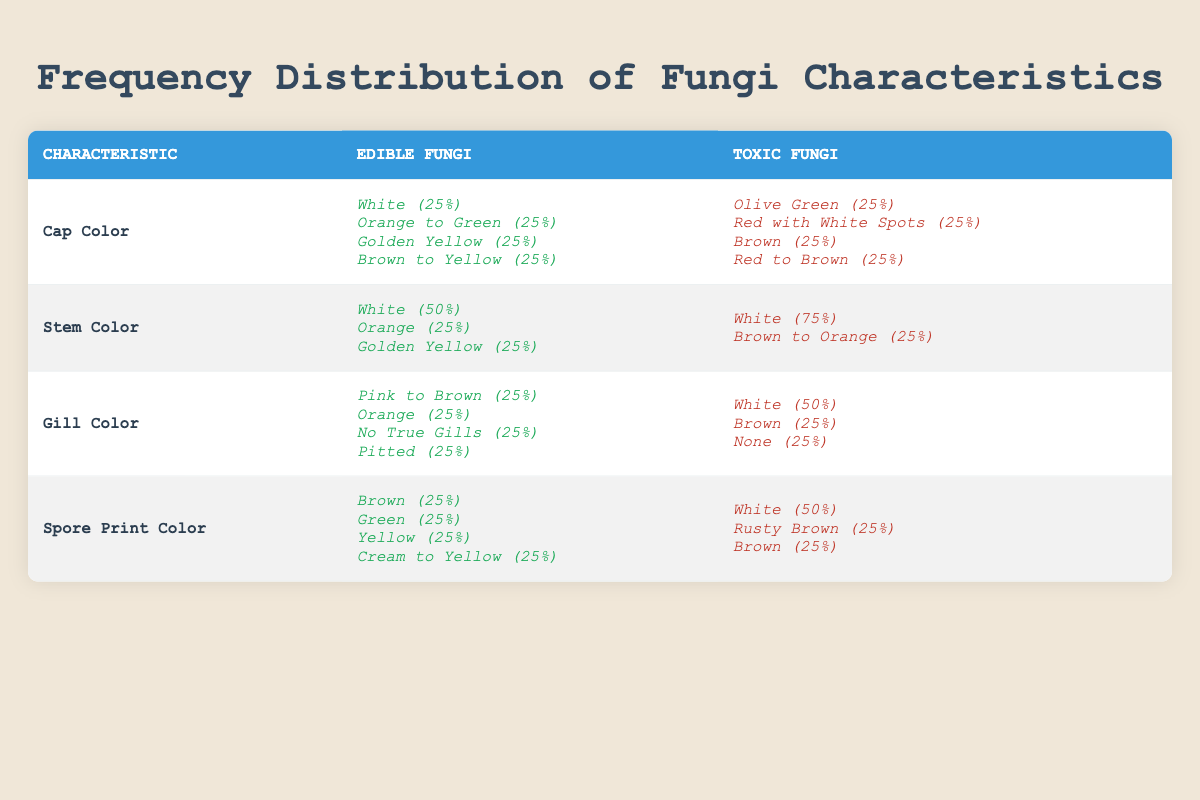What is the most common cap color among edible fungi? By referring to the table under the "Cap Color" characteristic for edible fungi, we see that there are four species, each with different colors: white, orange to green, golden yellow, and brown to yellow. Each of these colors occupies 25% frequency, indicating that there is no single most common color.
Answer: None How many different stem colors are found for toxic fungi? In examining the "Stem Color" section for toxic fungi, we find two unique colors: white and brown to orange. Therefore, there are two distinct stem colors in the toxic category.
Answer: 2 Which group has a higher percentage of white as a gill color? The table shows that for edible fungi, 25% have pink to brown, orange, no true gills, and pitted. In contrast, for toxic fungi, 50% have white as a gill color, compared to 25% in the edible category. Therefore, toxic fungi have a higher percentage.
Answer: Toxic fungi What is the unique spore print color for Lactarius deliciosus? In the "Spore Print Color" section for edible fungi, Lactarius deliciosus has a spore print color of green, which is not shared with the others. Therefore, this is the unique spore print color for this species.
Answer: Green How does the frequency of white stem color compare between edible and toxic fungi? The edible fungi show a frequency of 50% for white stem color, while toxic fungi show a frequency of 75%. To compare them, we find that toxic fungi have 25% more frequency than edible fungi for the white stem color.
Answer: 25% more frequency Which gill color appears in the largest percentage among edible fungi? Each gill color for edible fungi occupies 25%. Since there are four colors that equally contribute to the gill color characteristic, no single color has a larger percentage.
Answer: None What is the average frequency of spore print colors for edible fungi? The spore print colors for edible fungi are brown, green, yellow, and cream to yellow, each with a frequency of 25%. Since they are equal, the average frequency is (25 + 25 + 25 + 25) / 4 = 25%.
Answer: 25% Which is a common characteristic observed in toxic fungi based on the frequency distribution? Analyzing the "Cap Color" section, all four toxic fungi exhibit a distinct cap color: olive green, red with white spots, brown, and red to brown, with each color at 25%. Therefore, all these represents common characteristics.
Answer: Cap colors of four species 